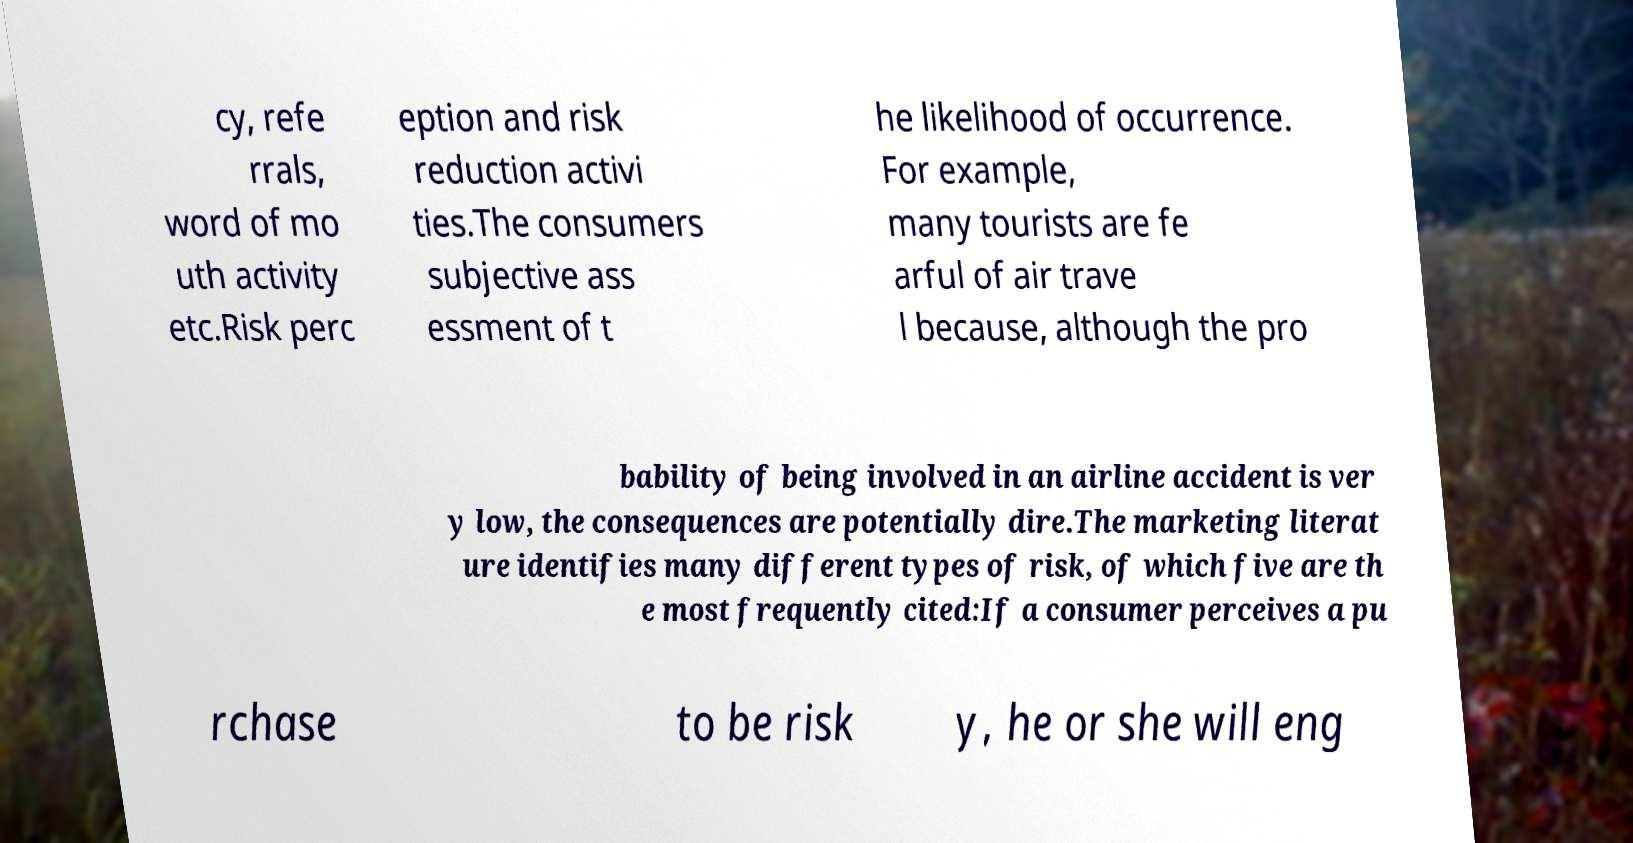Please read and relay the text visible in this image. What does it say? cy, refe rrals, word of mo uth activity etc.Risk perc eption and risk reduction activi ties.The consumers subjective ass essment of t he likelihood of occurrence. For example, many tourists are fe arful of air trave l because, although the pro bability of being involved in an airline accident is ver y low, the consequences are potentially dire.The marketing literat ure identifies many different types of risk, of which five are th e most frequently cited:If a consumer perceives a pu rchase to be risk y, he or she will eng 